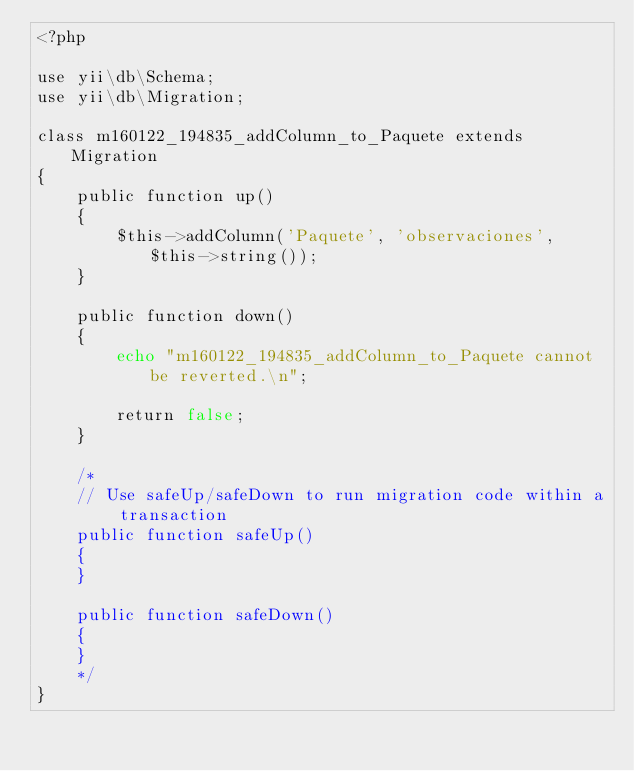Convert code to text. <code><loc_0><loc_0><loc_500><loc_500><_PHP_><?php

use yii\db\Schema;
use yii\db\Migration;

class m160122_194835_addColumn_to_Paquete extends Migration
{
    public function up()
    {
        $this->addColumn('Paquete', 'observaciones', $this->string());
    }

    public function down()
    {
        echo "m160122_194835_addColumn_to_Paquete cannot be reverted.\n";

        return false;
    }

    /*
    // Use safeUp/safeDown to run migration code within a transaction
    public function safeUp()
    {
    }

    public function safeDown()
    {
    }
    */
}
</code> 